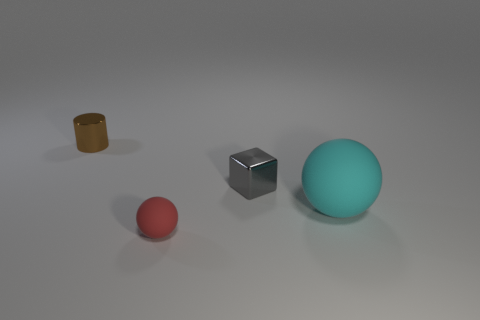Does the tiny gray metallic object have the same shape as the large rubber thing?
Your response must be concise. No. How many other things are there of the same size as the brown metallic thing?
Ensure brevity in your answer.  2. What number of things are objects that are behind the big object or cyan cylinders?
Your answer should be compact. 2. How many brown cylinders are the same material as the cyan thing?
Keep it short and to the point. 0. Is there another small metal object that has the same shape as the small brown shiny thing?
Keep it short and to the point. No. There is a gray thing that is the same size as the red sphere; what is its shape?
Keep it short and to the point. Cube. What number of big things are behind the tiny shiny thing that is on the left side of the gray thing?
Keep it short and to the point. 0. What size is the object that is to the left of the tiny gray metal cube and behind the red rubber ball?
Make the answer very short. Small. Is there a gray object that has the same size as the brown metal object?
Offer a very short reply. Yes. Are there more small metallic things on the right side of the tiny brown shiny cylinder than big objects that are to the right of the cyan ball?
Offer a very short reply. Yes. 